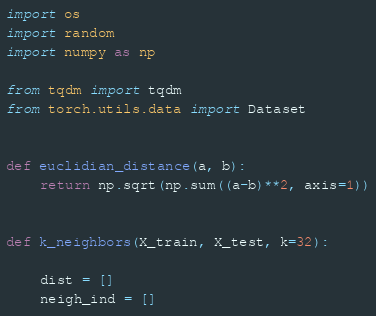Convert code to text. <code><loc_0><loc_0><loc_500><loc_500><_Python_>import os
import random
import numpy as np

from tqdm import tqdm
from torch.utils.data import Dataset


def euclidian_distance(a, b):
    return np.sqrt(np.sum((a-b)**2, axis=1))


def k_neighbors(X_train, X_test, k=32):

    dist = [] 
    neigh_ind = []
</code> 